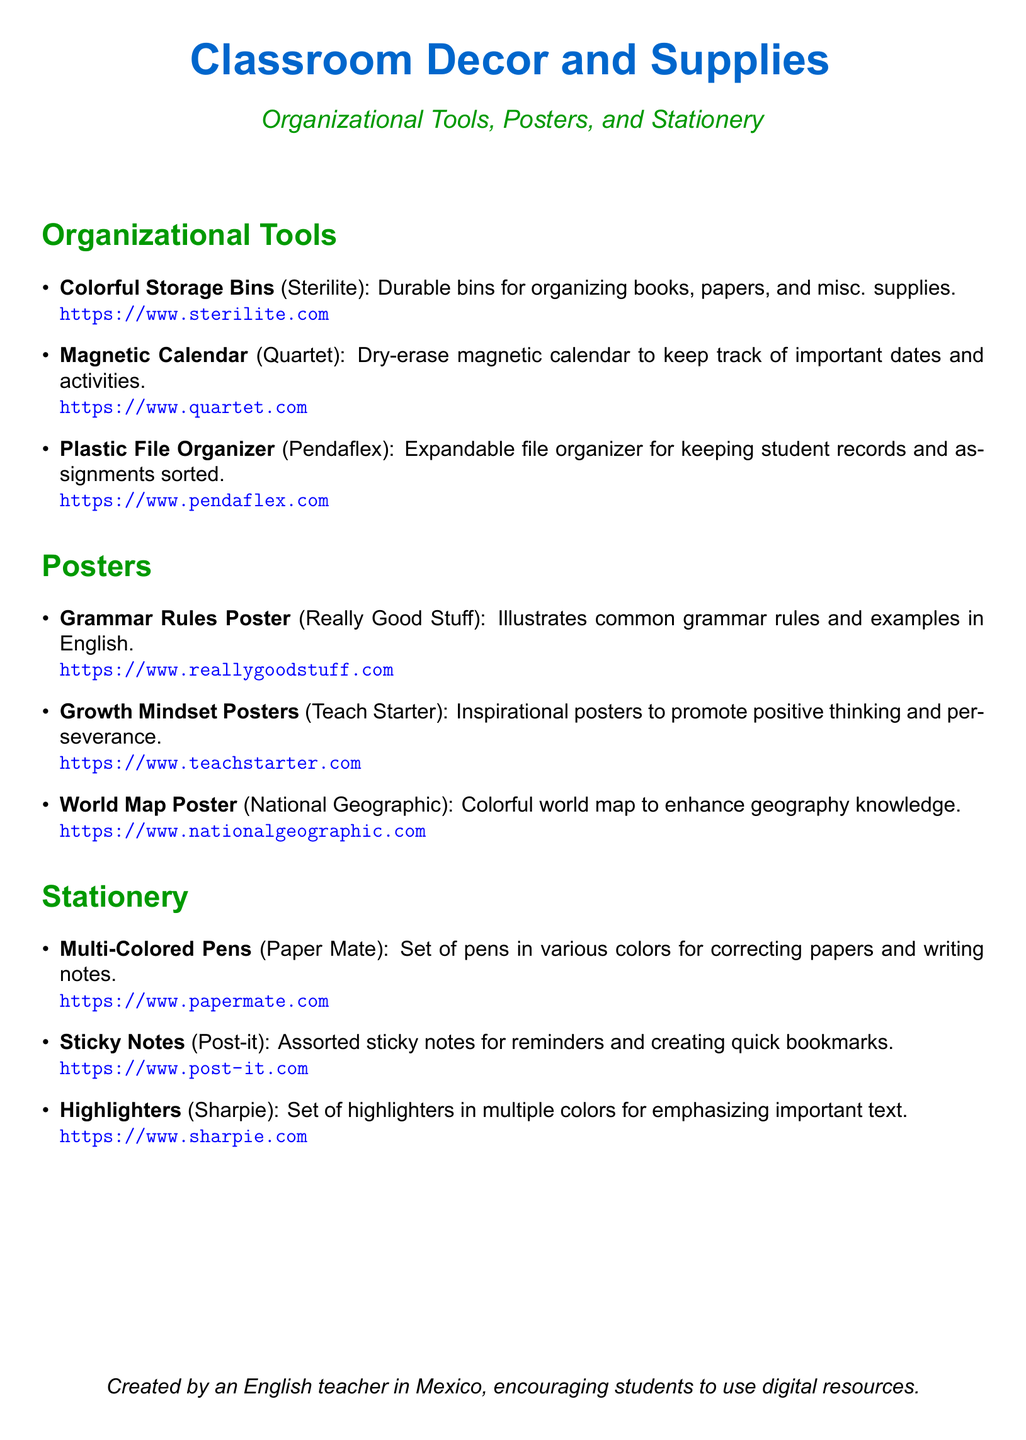What are the storage bins used for? The storage bins are used for organizing books, papers, and misc. supplies.
Answer: Organizing books, papers, and misc. supplies Which company makes the magnetic calendar? The company that makes the magnetic calendar is mentioned in the document.
Answer: Quartet How many types of posters are listed? The document lists three types of posters: Grammar Rules, Growth Mindset, and World Map.
Answer: Three What type of stationery is mentioned for highlighting text? The document specifies a certain type of stationery for emphasizing important text.
Answer: Highlighters What is the color of the title in the document? The title color is defined at the beginning of the document.
Answer: RGB(0,102,204) How many items are listed under Organizational Tools? The document lists items under Organizational Tools.
Answer: Three What is one of the uses for sticky notes? The document discusses the use of sticky notes.
Answer: Reminders What material are the multi-colored pens made by? The document mentions the producer of the multi-colored pens.
Answer: Paper Mate 